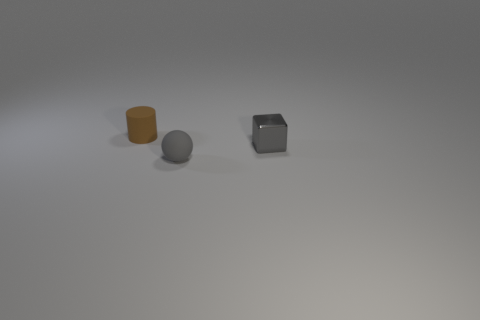Are there any other things that have the same shape as the tiny gray metallic object?
Provide a short and direct response. No. The brown rubber object has what size?
Give a very brief answer. Small. Is the number of small gray shiny cubes in front of the tiny gray sphere less than the number of tiny yellow objects?
Provide a succinct answer. No. Do the cube and the brown thing have the same size?
Provide a short and direct response. Yes. What color is the tiny thing that is made of the same material as the tiny cylinder?
Your answer should be compact. Gray. Is the number of matte spheres left of the block less than the number of tiny things behind the rubber ball?
Your answer should be very brief. Yes. What number of other cylinders have the same color as the cylinder?
Keep it short and to the point. 0. There is a ball that is the same color as the block; what is its material?
Make the answer very short. Rubber. How many objects are both on the right side of the rubber cylinder and left of the small block?
Make the answer very short. 1. What is the gray object that is right of the tiny gray ball that is in front of the metal cube made of?
Keep it short and to the point. Metal. 